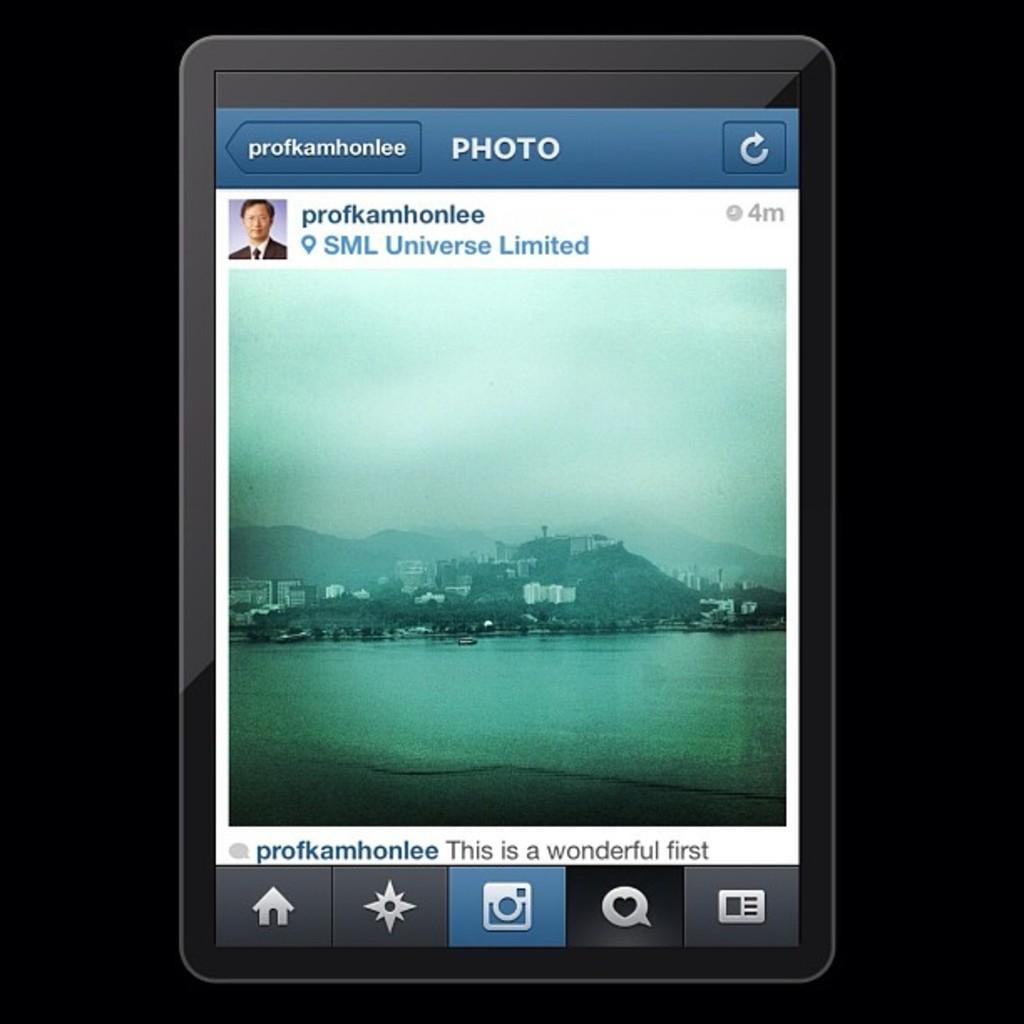How long ago was this photo posted?
Offer a terse response. 4 minutes. What is the posters username?
Your answer should be very brief. Profkamhonlee. 